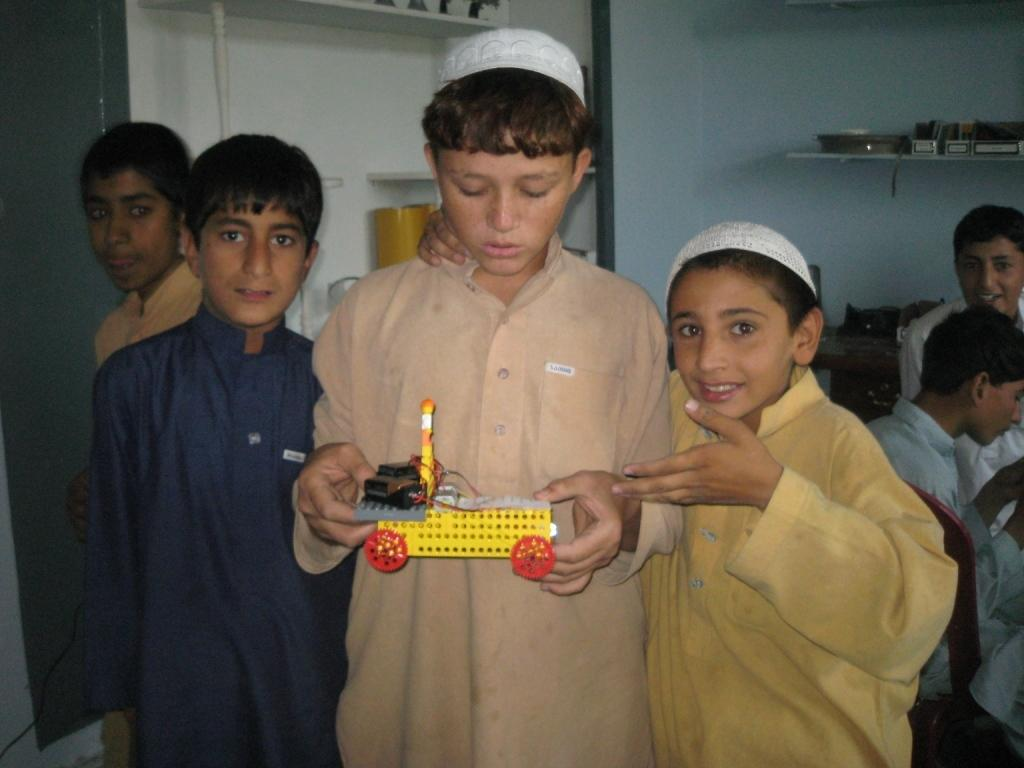Who is present in the image? There are children in the image. What is the boy holding in the image? The boy is holding a toy. What can be seen in the background of the image? There are objects on shelves in the background of the image. What type of animals can be seen at the zoo in the image? There is no zoo present in the image, so it is not possible to determine what, if any, animals might be seen. 